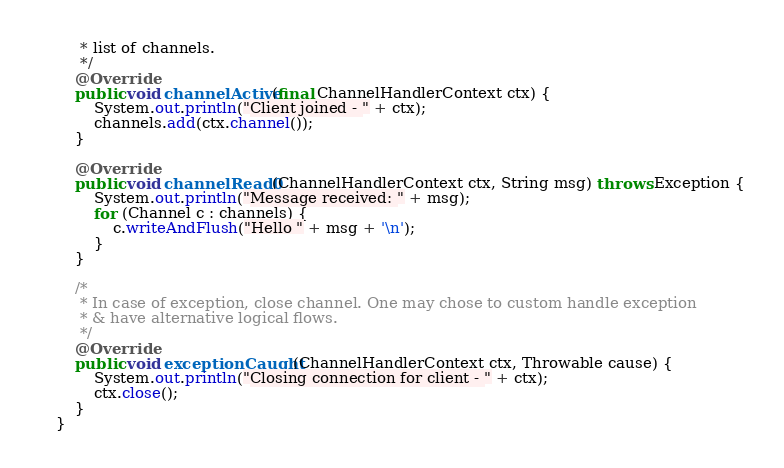Convert code to text. <code><loc_0><loc_0><loc_500><loc_500><_Java_>	 * list of channels.
	 */
	@Override
	public void channelActive(final ChannelHandlerContext ctx) {
		System.out.println("Client joined - " + ctx);
		channels.add(ctx.channel());
	}

	@Override
	public void channelRead0(ChannelHandlerContext ctx, String msg) throws Exception {
		System.out.println("Message received: " + msg);
		for (Channel c : channels) {
			c.writeAndFlush("Hello " + msg + '\n');
		}
	}

	/*
	 * In case of exception, close channel. One may chose to custom handle exception
	 * & have alternative logical flows.
	 */
	@Override
	public void exceptionCaught(ChannelHandlerContext ctx, Throwable cause) {
		System.out.println("Closing connection for client - " + ctx);
		ctx.close();
	}
}</code> 